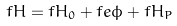<formula> <loc_0><loc_0><loc_500><loc_500>f H = f H _ { 0 } + f e \phi + f H _ { P }</formula> 